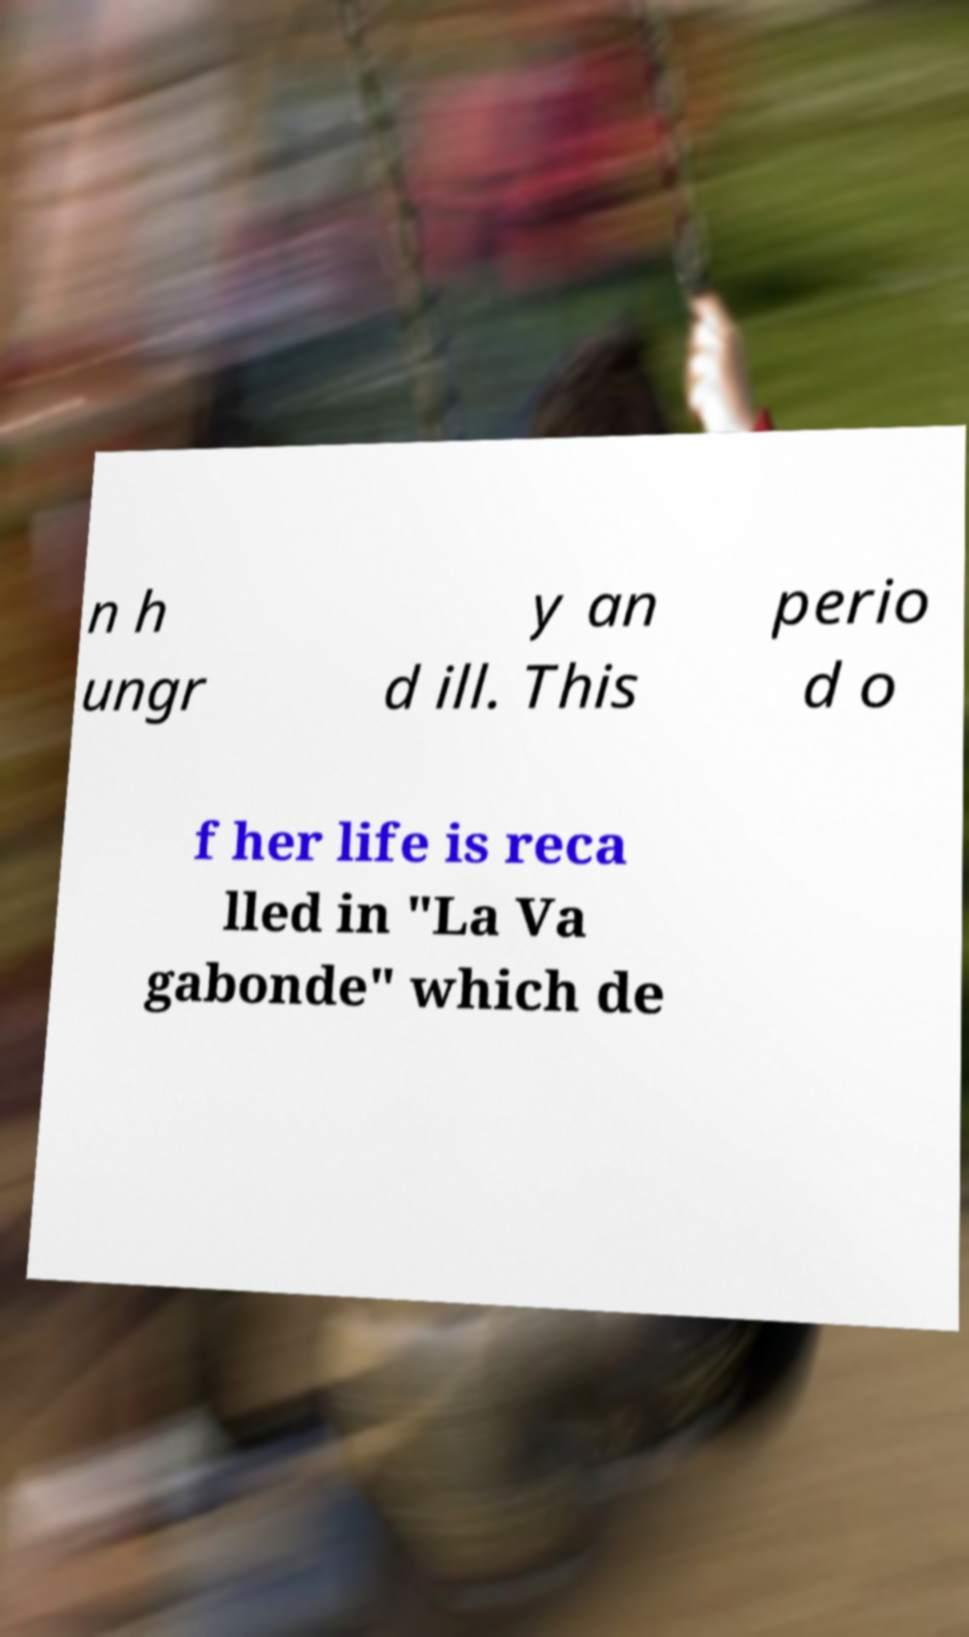Please read and relay the text visible in this image. What does it say? n h ungr y an d ill. This perio d o f her life is reca lled in "La Va gabonde" which de 